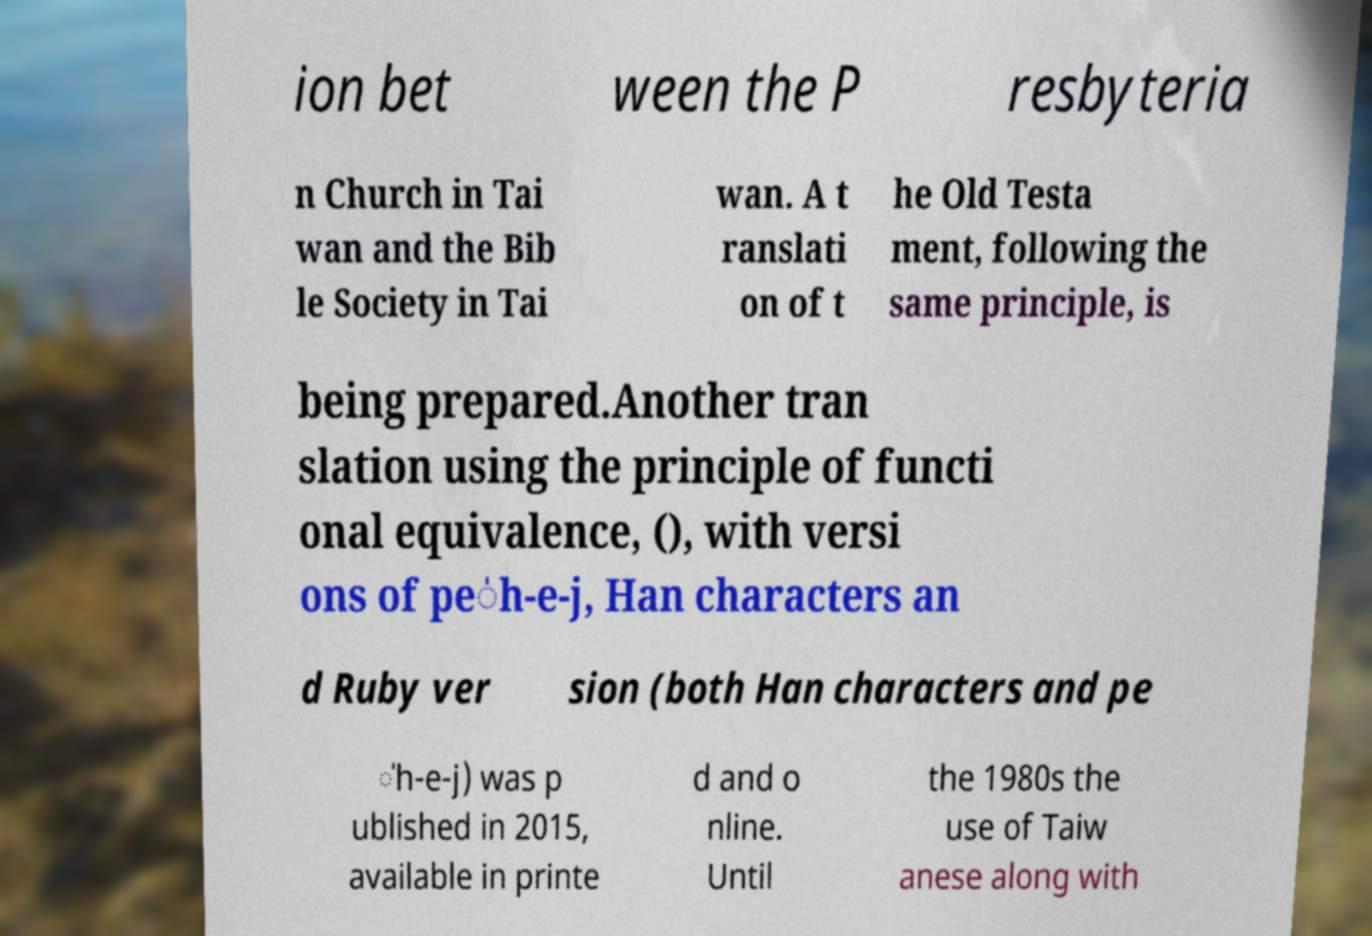There's text embedded in this image that I need extracted. Can you transcribe it verbatim? ion bet ween the P resbyteria n Church in Tai wan and the Bib le Society in Tai wan. A t ranslati on of t he Old Testa ment, following the same principle, is being prepared.Another tran slation using the principle of functi onal equivalence, (), with versi ons of pe̍h-e-j, Han characters an d Ruby ver sion (both Han characters and pe ̍h-e-j) was p ublished in 2015, available in printe d and o nline. Until the 1980s the use of Taiw anese along with 